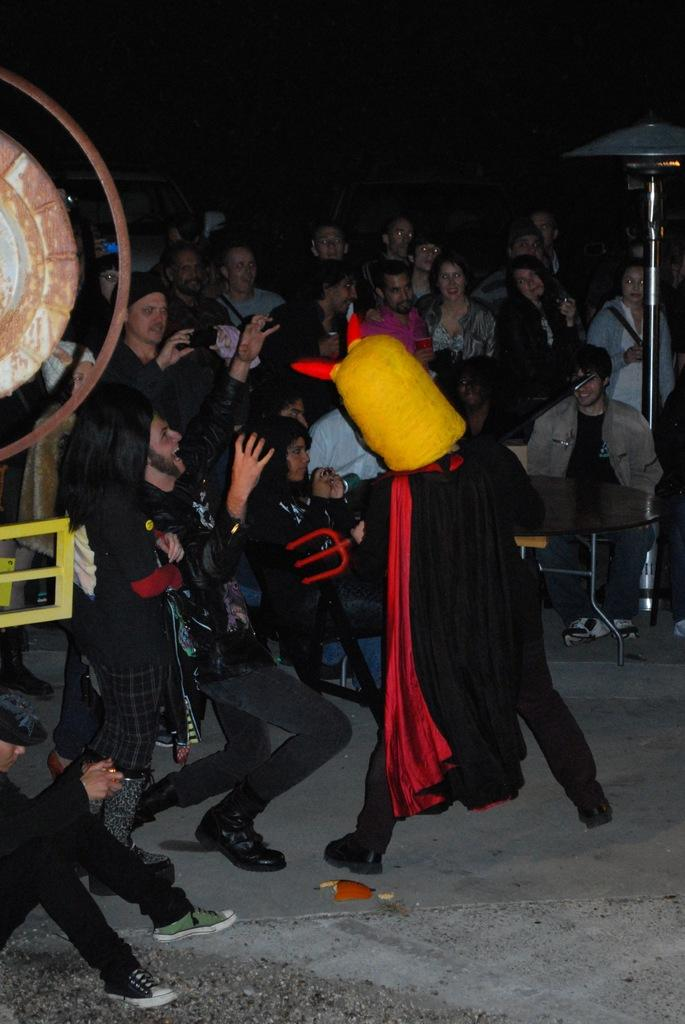What is the person in the image doing? The person is standing in the image. What is the person wearing on their face? The person is wearing a mask. What color is the dress the person is wearing? The person is wearing a black dress. Are there any other people in the image? Yes, other people are present in the image. What type of furniture can be seen in the image? There is a table in the image. What is located at the back of the image? There is a stand at the back of the image. What type of emotion can be seen on the person's face due to the oranges in the image? There are no oranges present in the image, so it is not possible to determine the person's emotion based on them. 